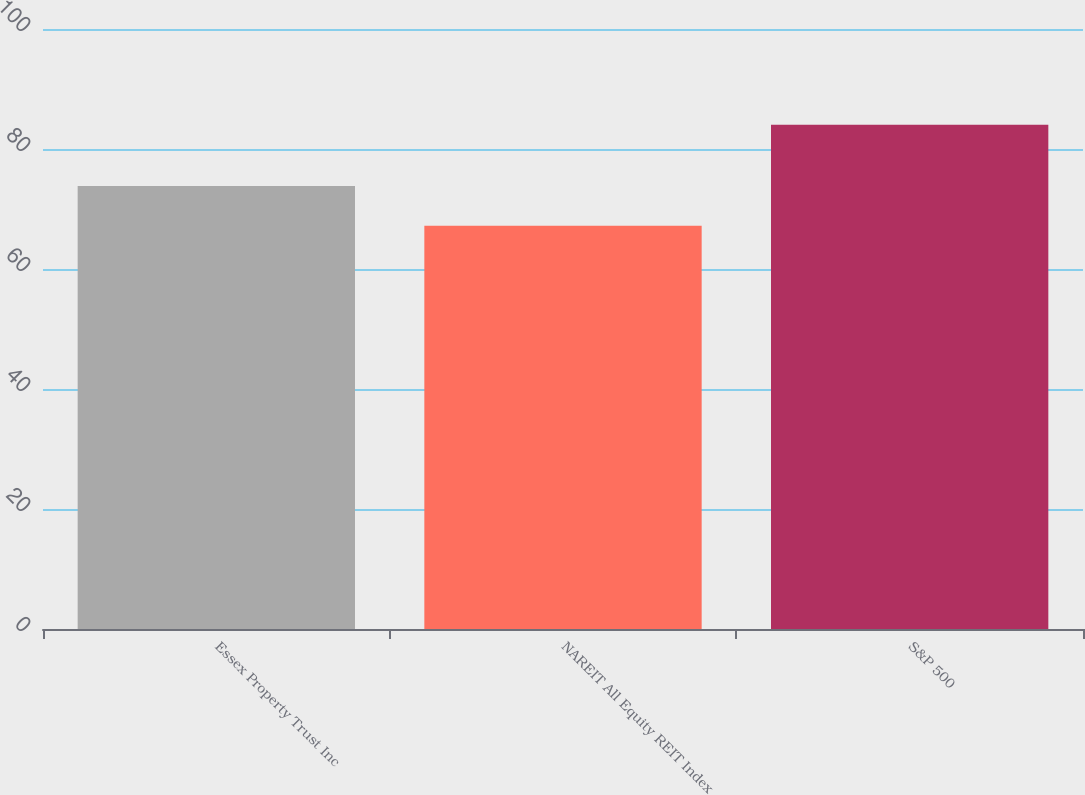Convert chart. <chart><loc_0><loc_0><loc_500><loc_500><bar_chart><fcel>Essex Property Trust Inc<fcel>NAREIT All Equity REIT Index<fcel>S&P 500<nl><fcel>73.84<fcel>67.2<fcel>84.05<nl></chart> 